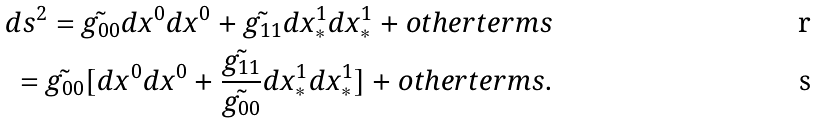<formula> <loc_0><loc_0><loc_500><loc_500>d s ^ { 2 } = \tilde { g _ { 0 0 } } d x ^ { 0 } d x ^ { 0 } + \tilde { g _ { 1 1 } } d x ^ { 1 } _ { * } d x ^ { 1 } _ { * } + o t h e r t e r m s \\ = \tilde { g _ { 0 0 } } [ d x ^ { 0 } d x ^ { 0 } + \frac { \tilde { g _ { 1 1 } } } { \tilde { g _ { 0 0 } } } d x ^ { 1 } _ { * } d x ^ { 1 } _ { * } ] + o t h e r t e r m s .</formula> 